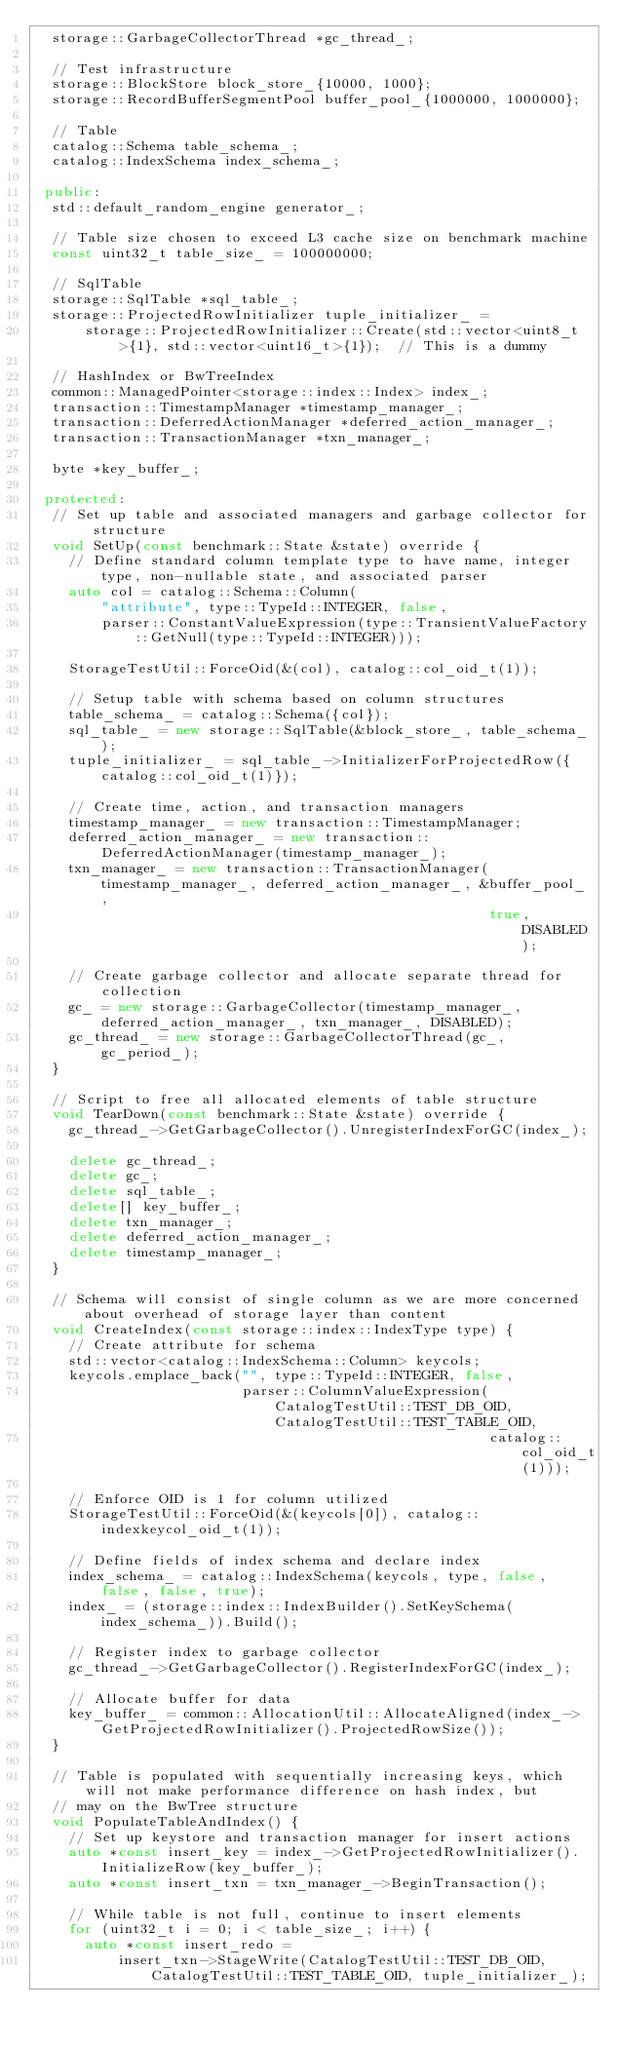Convert code to text. <code><loc_0><loc_0><loc_500><loc_500><_C++_>  storage::GarbageCollectorThread *gc_thread_;

  // Test infrastructure
  storage::BlockStore block_store_{10000, 1000};
  storage::RecordBufferSegmentPool buffer_pool_{1000000, 1000000};

  // Table
  catalog::Schema table_schema_;
  catalog::IndexSchema index_schema_;

 public:
  std::default_random_engine generator_;

  // Table size chosen to exceed L3 cache size on benchmark machine
  const uint32_t table_size_ = 100000000;

  // SqlTable
  storage::SqlTable *sql_table_;
  storage::ProjectedRowInitializer tuple_initializer_ =
      storage::ProjectedRowInitializer::Create(std::vector<uint8_t>{1}, std::vector<uint16_t>{1});  // This is a dummy

  // HashIndex or BwTreeIndex
  common::ManagedPointer<storage::index::Index> index_;
  transaction::TimestampManager *timestamp_manager_;
  transaction::DeferredActionManager *deferred_action_manager_;
  transaction::TransactionManager *txn_manager_;

  byte *key_buffer_;

 protected:
  // Set up table and associated managers and garbage collector for structure
  void SetUp(const benchmark::State &state) override {
    // Define standard column template type to have name, integer type, non-nullable state, and associated parser
    auto col = catalog::Schema::Column(
        "attribute", type::TypeId::INTEGER, false,
        parser::ConstantValueExpression(type::TransientValueFactory::GetNull(type::TypeId::INTEGER)));

    StorageTestUtil::ForceOid(&(col), catalog::col_oid_t(1));

    // Setup table with schema based on column structures
    table_schema_ = catalog::Schema({col});
    sql_table_ = new storage::SqlTable(&block_store_, table_schema_);
    tuple_initializer_ = sql_table_->InitializerForProjectedRow({catalog::col_oid_t(1)});

    // Create time, action, and transaction managers
    timestamp_manager_ = new transaction::TimestampManager;
    deferred_action_manager_ = new transaction::DeferredActionManager(timestamp_manager_);
    txn_manager_ = new transaction::TransactionManager(timestamp_manager_, deferred_action_manager_, &buffer_pool_,
                                                       true, DISABLED);

    // Create garbage collector and allocate separate thread for collection
    gc_ = new storage::GarbageCollector(timestamp_manager_, deferred_action_manager_, txn_manager_, DISABLED);
    gc_thread_ = new storage::GarbageCollectorThread(gc_, gc_period_);
  }

  // Script to free all allocated elements of table structure
  void TearDown(const benchmark::State &state) override {
    gc_thread_->GetGarbageCollector().UnregisterIndexForGC(index_);

    delete gc_thread_;
    delete gc_;
    delete sql_table_;
    delete[] key_buffer_;
    delete txn_manager_;
    delete deferred_action_manager_;
    delete timestamp_manager_;
  }

  // Schema will consist of single column as we are more concerned about overhead of storage layer than content
  void CreateIndex(const storage::index::IndexType type) {
    // Create attribute for schema
    std::vector<catalog::IndexSchema::Column> keycols;
    keycols.emplace_back("", type::TypeId::INTEGER, false,
                         parser::ColumnValueExpression(CatalogTestUtil::TEST_DB_OID, CatalogTestUtil::TEST_TABLE_OID,
                                                       catalog::col_oid_t(1)));

    // Enforce OID is 1 for column utilized
    StorageTestUtil::ForceOid(&(keycols[0]), catalog::indexkeycol_oid_t(1));

    // Define fields of index schema and declare index
    index_schema_ = catalog::IndexSchema(keycols, type, false, false, false, true);
    index_ = (storage::index::IndexBuilder().SetKeySchema(index_schema_)).Build();

    // Register index to garbage collector
    gc_thread_->GetGarbageCollector().RegisterIndexForGC(index_);

    // Allocate buffer for data
    key_buffer_ = common::AllocationUtil::AllocateAligned(index_->GetProjectedRowInitializer().ProjectedRowSize());
  }

  // Table is populated with sequentially increasing keys, which will not make performance difference on hash index, but
  // may on the BwTree structure
  void PopulateTableAndIndex() {
    // Set up keystore and transaction manager for insert actions
    auto *const insert_key = index_->GetProjectedRowInitializer().InitializeRow(key_buffer_);
    auto *const insert_txn = txn_manager_->BeginTransaction();

    // While table is not full, continue to insert elements
    for (uint32_t i = 0; i < table_size_; i++) {
      auto *const insert_redo =
          insert_txn->StageWrite(CatalogTestUtil::TEST_DB_OID, CatalogTestUtil::TEST_TABLE_OID, tuple_initializer_);</code> 